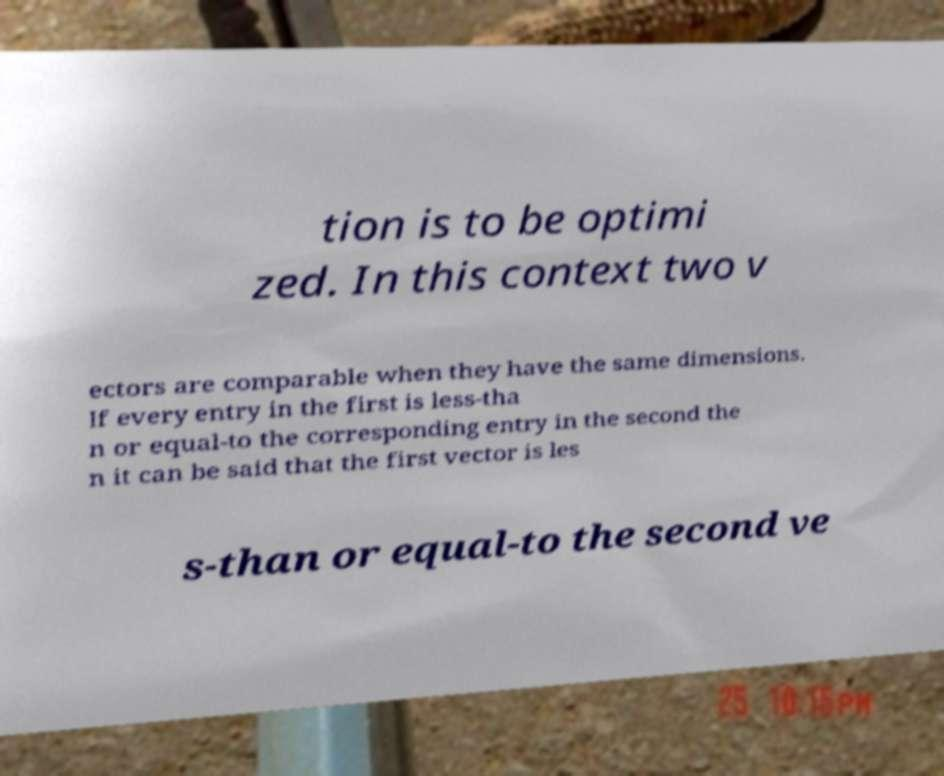Can you read and provide the text displayed in the image?This photo seems to have some interesting text. Can you extract and type it out for me? tion is to be optimi zed. In this context two v ectors are comparable when they have the same dimensions. If every entry in the first is less-tha n or equal-to the corresponding entry in the second the n it can be said that the first vector is les s-than or equal-to the second ve 